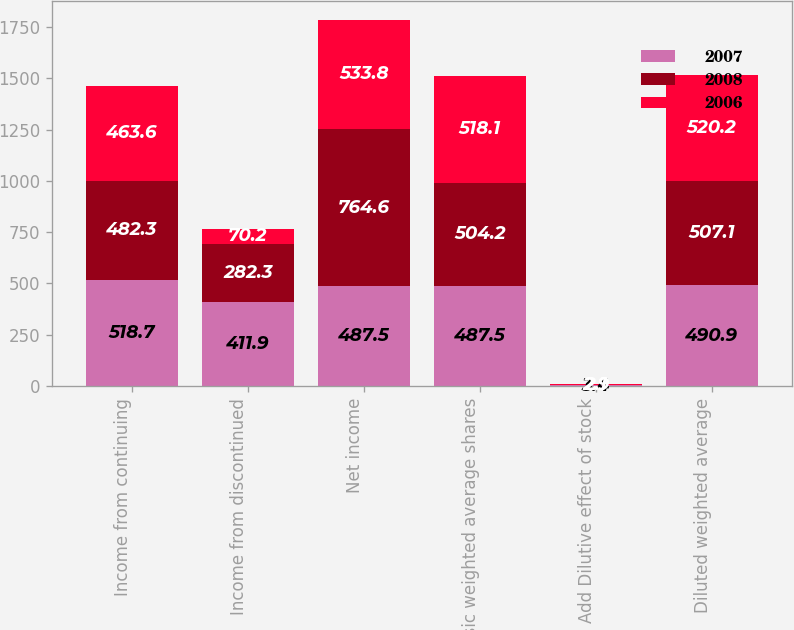Convert chart. <chart><loc_0><loc_0><loc_500><loc_500><stacked_bar_chart><ecel><fcel>Income from continuing<fcel>Income from discontinued<fcel>Net income<fcel>Basic weighted average shares<fcel>Add Dilutive effect of stock<fcel>Diluted weighted average<nl><fcel>2007<fcel>518.7<fcel>411.9<fcel>487.5<fcel>487.5<fcel>3.4<fcel>490.9<nl><fcel>2008<fcel>482.3<fcel>282.3<fcel>764.6<fcel>504.2<fcel>2.9<fcel>507.1<nl><fcel>2006<fcel>463.6<fcel>70.2<fcel>533.8<fcel>518.1<fcel>2.1<fcel>520.2<nl></chart> 